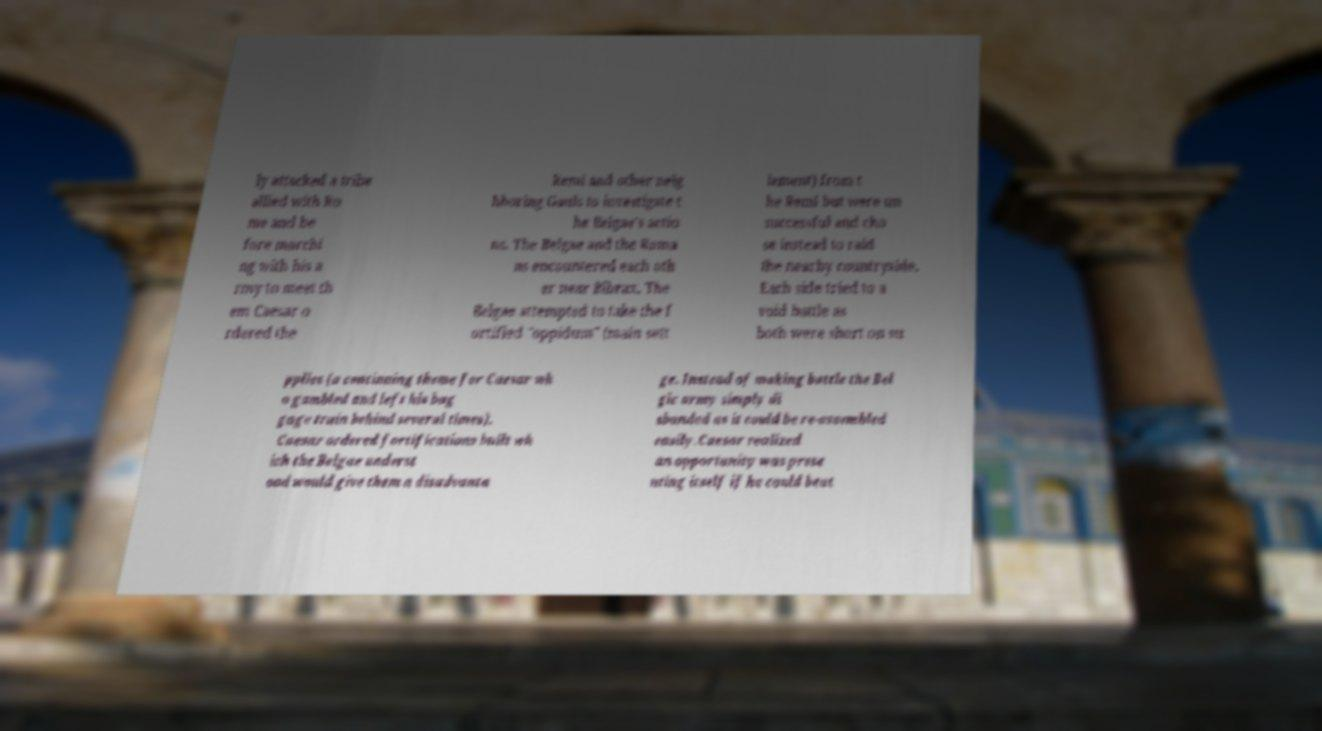I need the written content from this picture converted into text. Can you do that? ly attacked a tribe allied with Ro me and be fore marchi ng with his a rmy to meet th em Caesar o rdered the Remi and other neig hboring Gauls to investigate t he Belgae's actio ns. The Belgae and the Roma ns encountered each oth er near Bibrax. The Belgae attempted to take the f ortified "oppidum" (main sett lement) from t he Remi but were un successful and cho se instead to raid the nearby countryside. Each side tried to a void battle as both were short on su pplies (a continuing theme for Caesar wh o gambled and left his bag gage train behind several times). Caesar ordered fortifications built wh ich the Belgae underst ood would give them a disadvanta ge. Instead of making battle the Bel gic army simply di sbanded as it could be re-assembled easily.Caesar realized an opportunity was prese nting itself if he could beat 